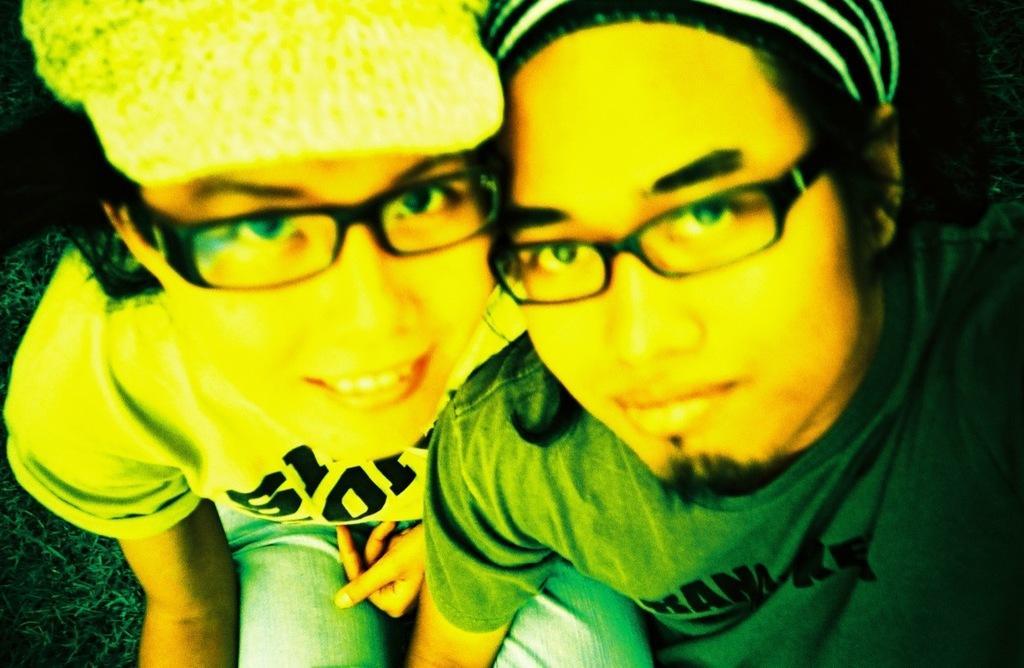Please provide a concise description of this image. In this image I can see a girl is sitting on the sofa, she wore spectacles, t-shirt, trouser and a cap. On the right side a man is also sitting. He wore green color t-shirt. 